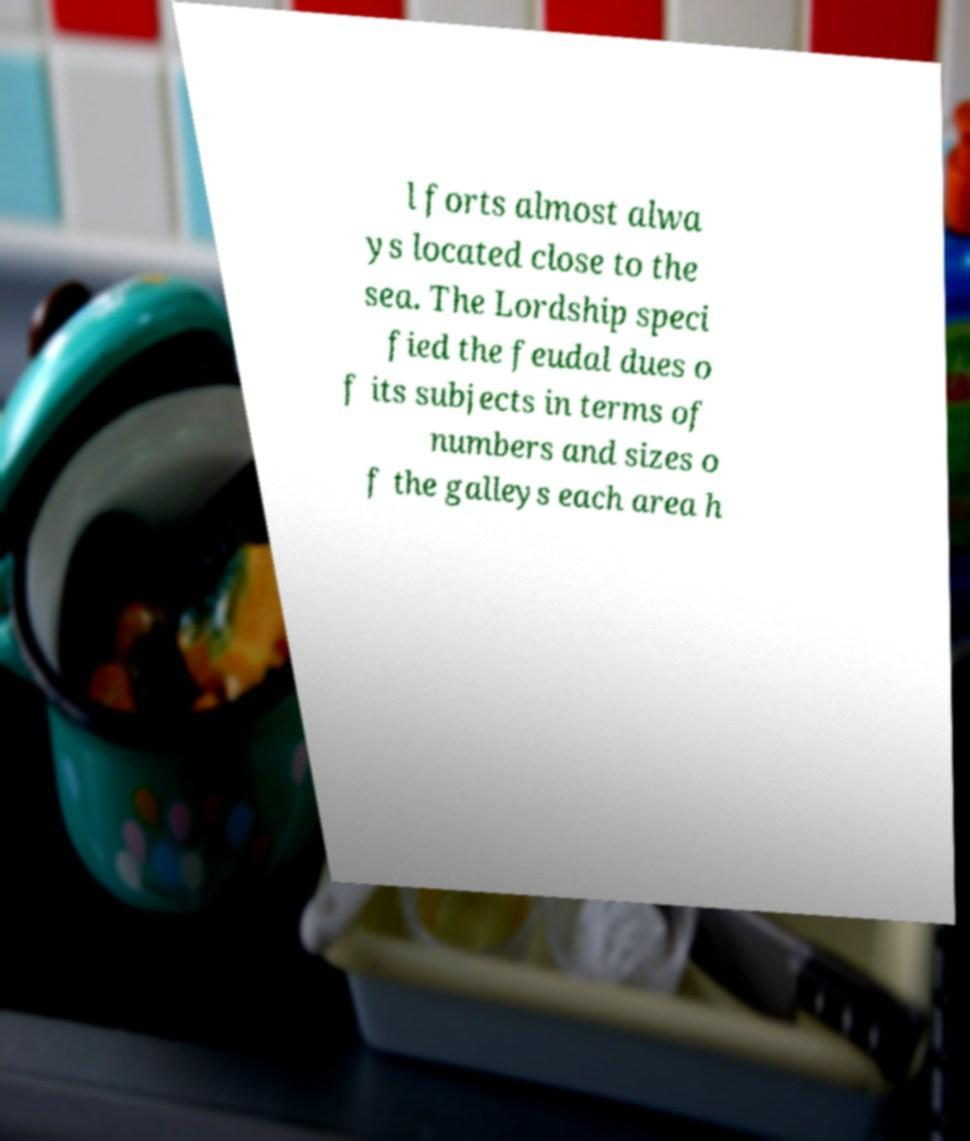I need the written content from this picture converted into text. Can you do that? l forts almost alwa ys located close to the sea. The Lordship speci fied the feudal dues o f its subjects in terms of numbers and sizes o f the galleys each area h 